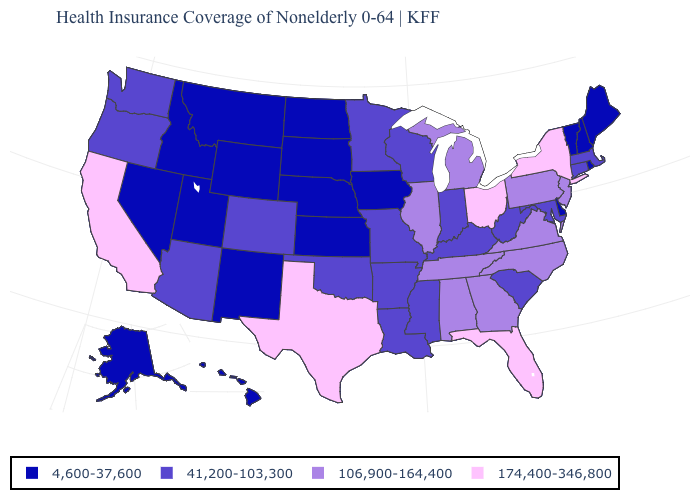What is the value of New Jersey?
Answer briefly. 106,900-164,400. How many symbols are there in the legend?
Keep it brief. 4. What is the value of Arizona?
Give a very brief answer. 41,200-103,300. What is the value of Arizona?
Give a very brief answer. 41,200-103,300. Does West Virginia have the same value as South Carolina?
Give a very brief answer. Yes. Does Texas have the highest value in the USA?
Quick response, please. Yes. What is the lowest value in the Northeast?
Be succinct. 4,600-37,600. Is the legend a continuous bar?
Write a very short answer. No. What is the value of North Carolina?
Short answer required. 106,900-164,400. What is the value of New York?
Answer briefly. 174,400-346,800. Which states have the highest value in the USA?
Keep it brief. California, Florida, New York, Ohio, Texas. Among the states that border North Dakota , does Montana have the highest value?
Write a very short answer. No. Among the states that border Michigan , does Indiana have the highest value?
Quick response, please. No. What is the highest value in the USA?
Give a very brief answer. 174,400-346,800. 